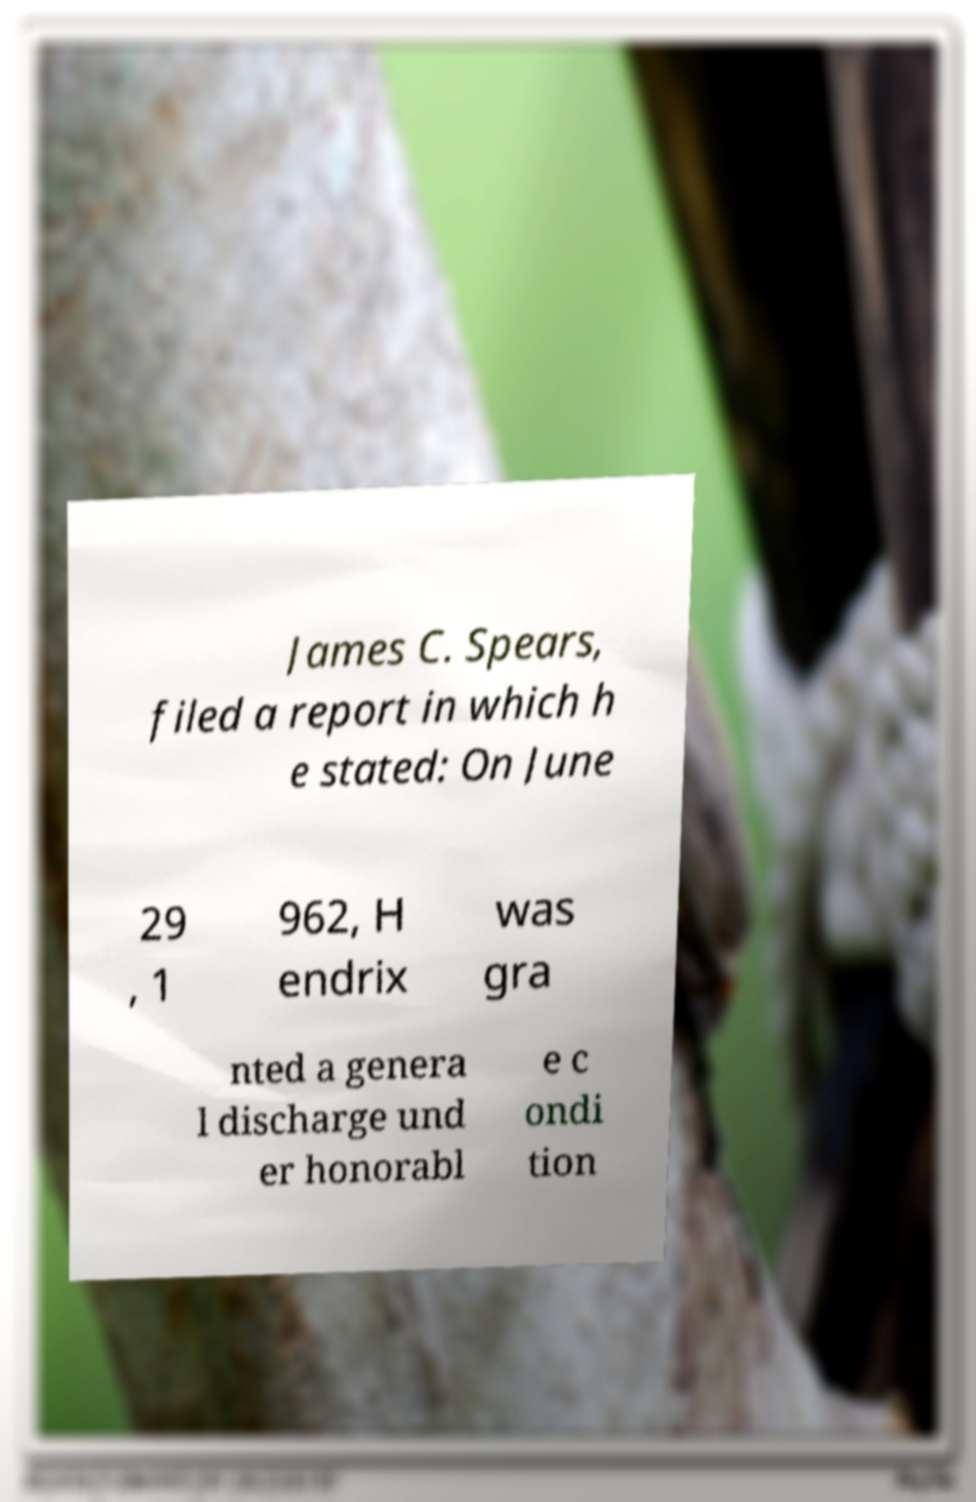Could you extract and type out the text from this image? James C. Spears, filed a report in which h e stated: On June 29 , 1 962, H endrix was gra nted a genera l discharge und er honorabl e c ondi tion 